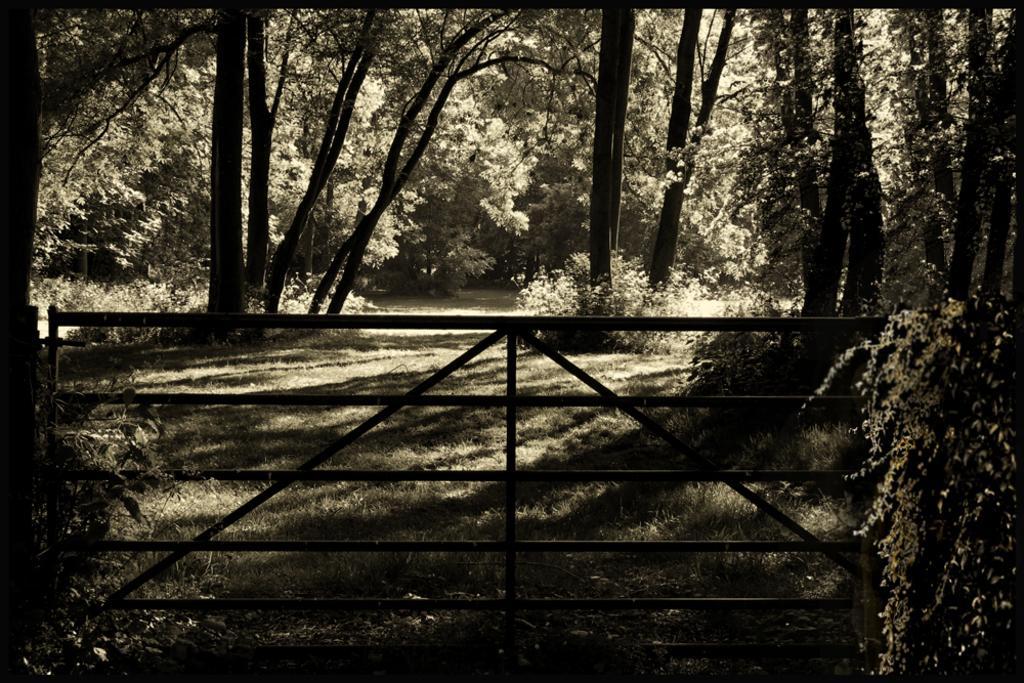How would you summarize this image in a sentence or two? Here there are trees, this is iron gate. 